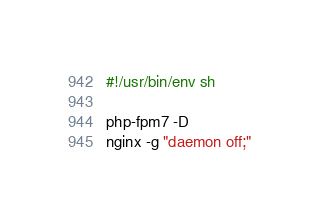<code> <loc_0><loc_0><loc_500><loc_500><_Bash_>#!/usr/bin/env sh

php-fpm7 -D
nginx -g "daemon off;"
</code> 